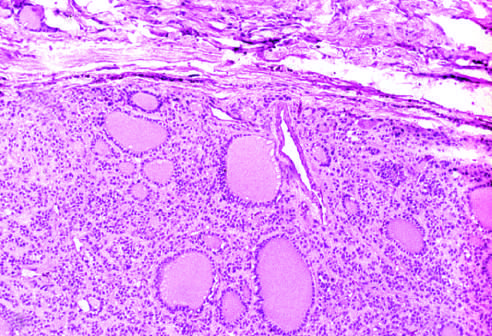does high magnification surround the neoplastic follicles?
Answer the question using a single word or phrase. No 